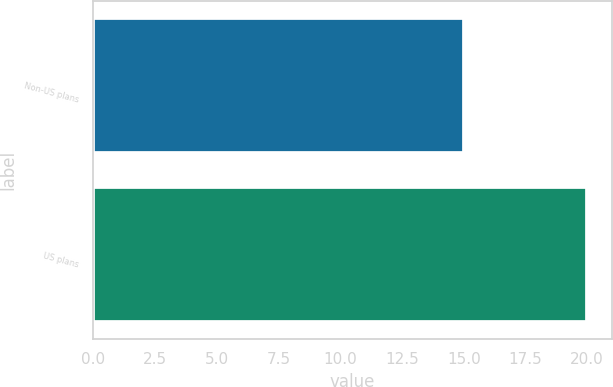Convert chart. <chart><loc_0><loc_0><loc_500><loc_500><bar_chart><fcel>Non-US plans<fcel>US plans<nl><fcel>15<fcel>20<nl></chart> 